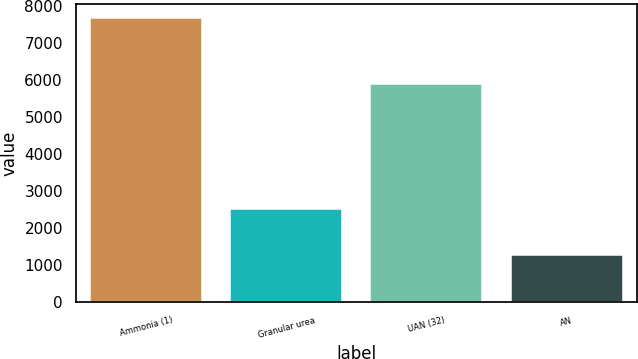Convert chart. <chart><loc_0><loc_0><loc_500><loc_500><bar_chart><fcel>Ammonia (1)<fcel>Granular urea<fcel>UAN (32)<fcel>AN<nl><fcel>7673<fcel>2520<fcel>5888<fcel>1283<nl></chart> 